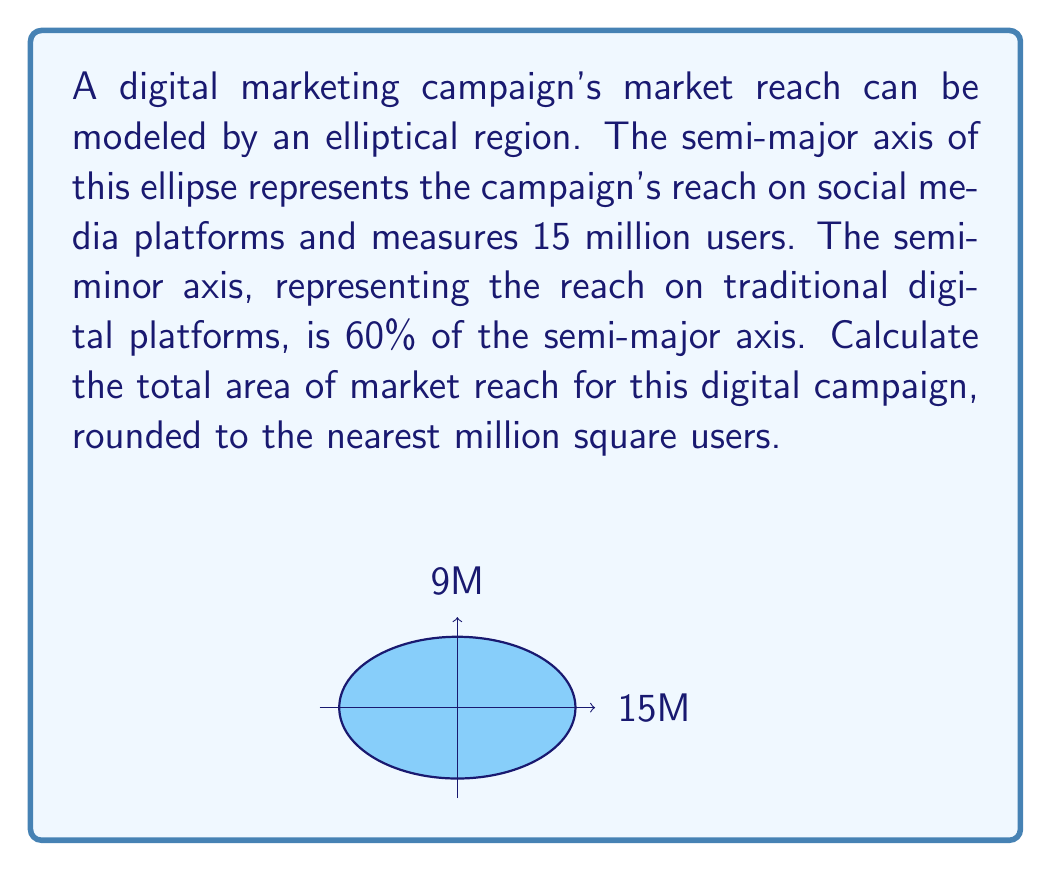Give your solution to this math problem. Let's approach this step-by-step:

1) We are given that the semi-major axis (a) is 15 million users.

2) The semi-minor axis (b) is 60% of the semi-major axis:
   $b = 0.60 \times 15 = 9$ million users

3) The formula for the area of an ellipse is:
   $$A = \pi ab$$
   where $a$ is the semi-major axis and $b$ is the semi-minor axis.

4) Substituting our values:
   $$A = \pi \times 15 \times 9$$

5) Simplify:
   $$A = 135\pi$$ million square users

6) Calculate and round to the nearest million:
   $$A \approx 424$$ million square users

Therefore, the total area of market reach for this digital campaign is approximately 424 million square users.
Answer: 424 million sq users 